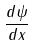<formula> <loc_0><loc_0><loc_500><loc_500>\frac { d \psi } { d x }</formula> 